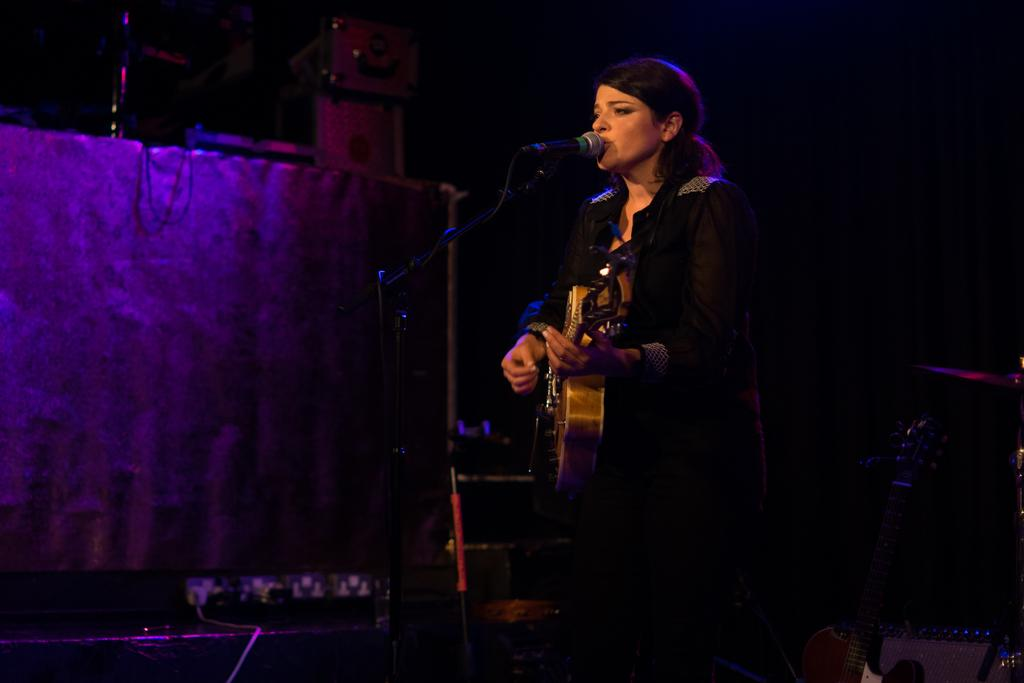Who is the main subject in the image? There is a woman in the image. What is the woman doing in the image? The woman is playing a guitar and singing. What object is present to amplify her voice? There is a microphone in the image. What other musical instruments can be seen in the image? There are devices on top of something in the image, and these devices are musical instruments. Can you see a wren perched on the guitar in the image? No, there is no wren present in the image. Is the woman recording her performance in the image? The image does not provide any information about recording the performance. 